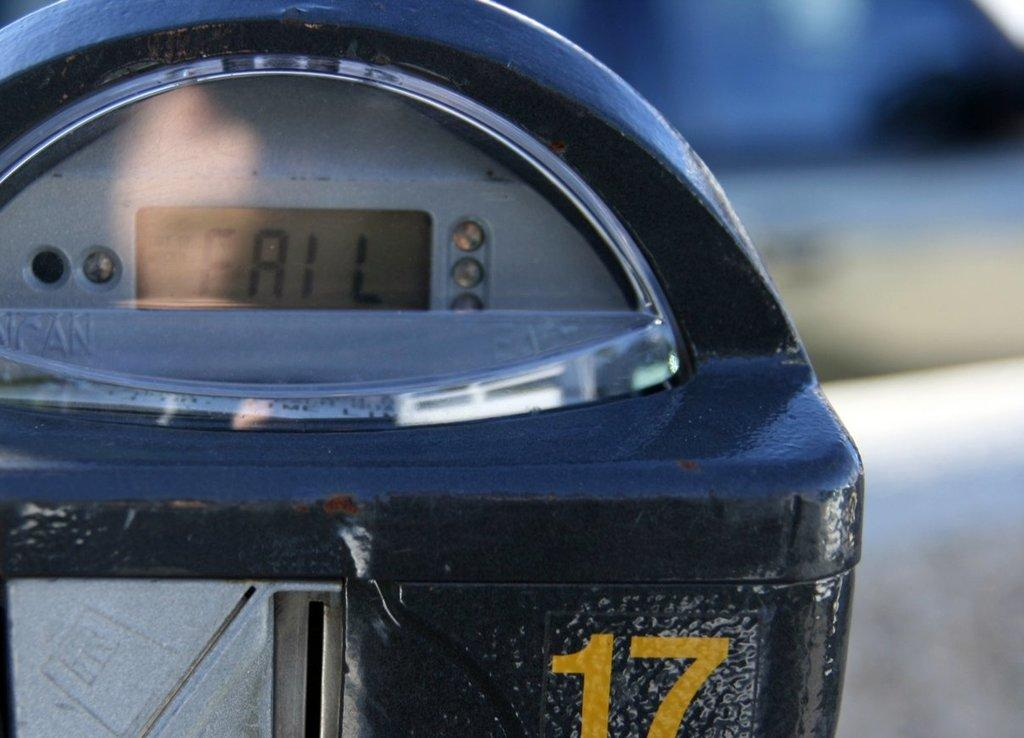<image>
Write a terse but informative summary of the picture. A parking meter with FAIL written in the display. 